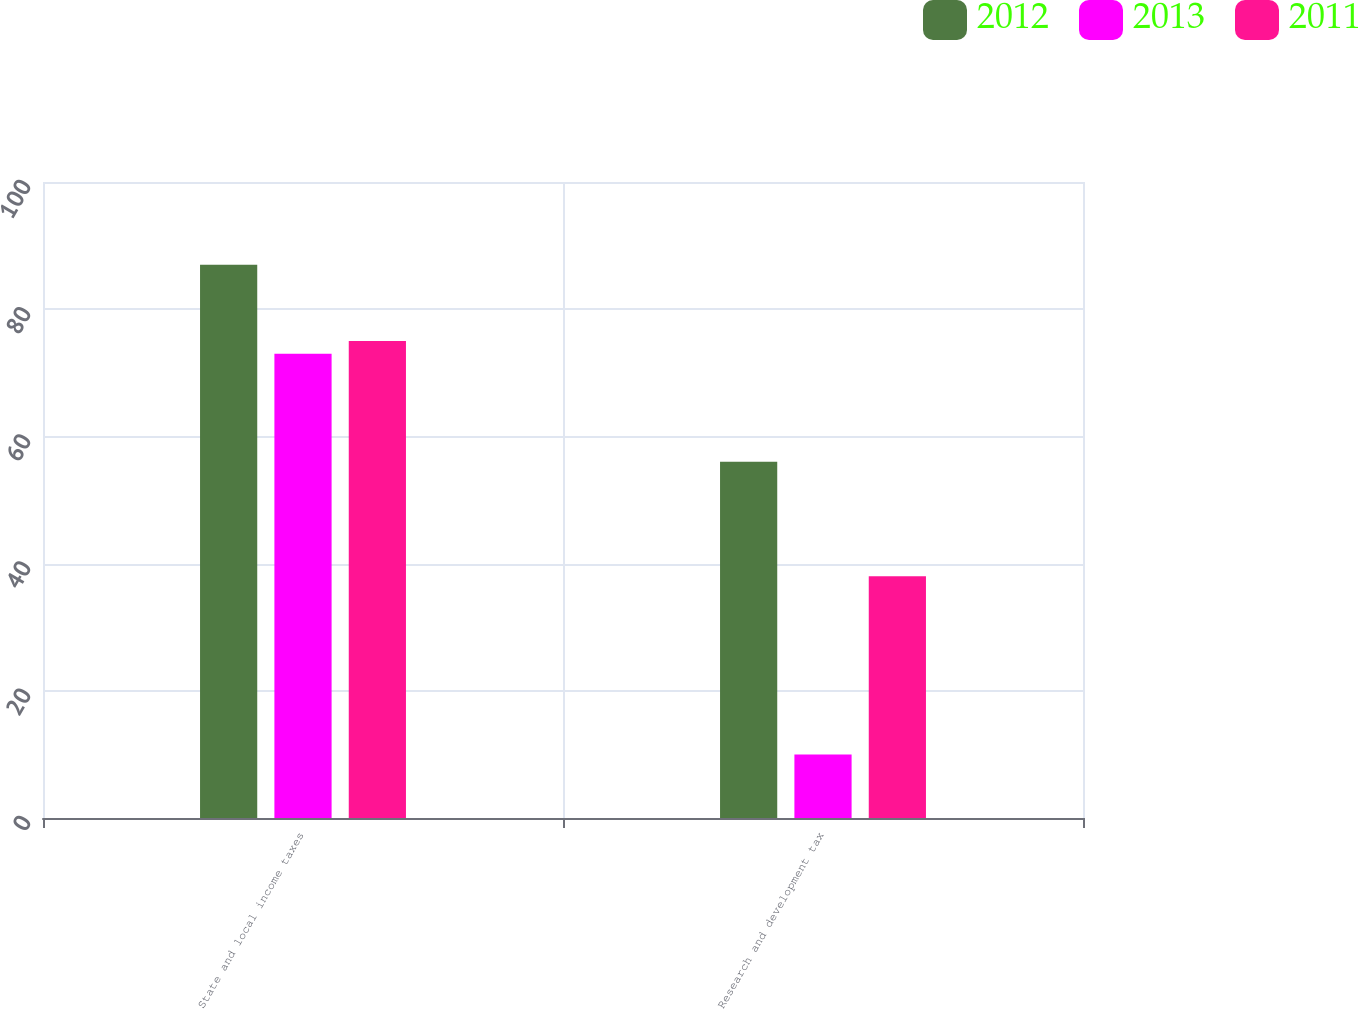<chart> <loc_0><loc_0><loc_500><loc_500><stacked_bar_chart><ecel><fcel>State and local income taxes<fcel>Research and development tax<nl><fcel>2012<fcel>87<fcel>56<nl><fcel>2013<fcel>73<fcel>10<nl><fcel>2011<fcel>75<fcel>38<nl></chart> 